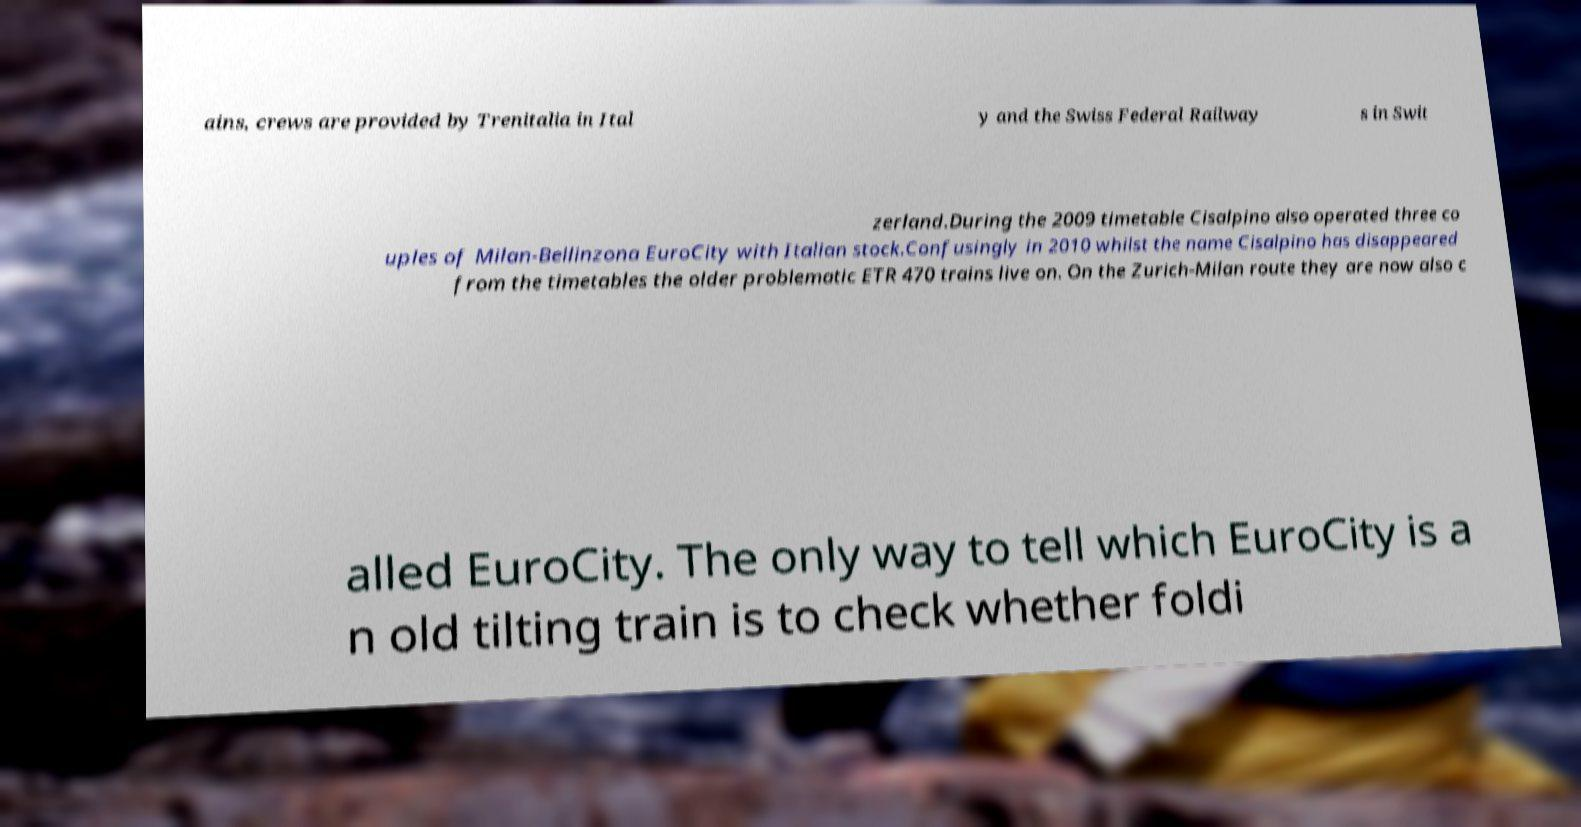Could you extract and type out the text from this image? ains, crews are provided by Trenitalia in Ital y and the Swiss Federal Railway s in Swit zerland.During the 2009 timetable Cisalpino also operated three co uples of Milan-Bellinzona EuroCity with Italian stock.Confusingly in 2010 whilst the name Cisalpino has disappeared from the timetables the older problematic ETR 470 trains live on. On the Zurich-Milan route they are now also c alled EuroCity. The only way to tell which EuroCity is a n old tilting train is to check whether foldi 